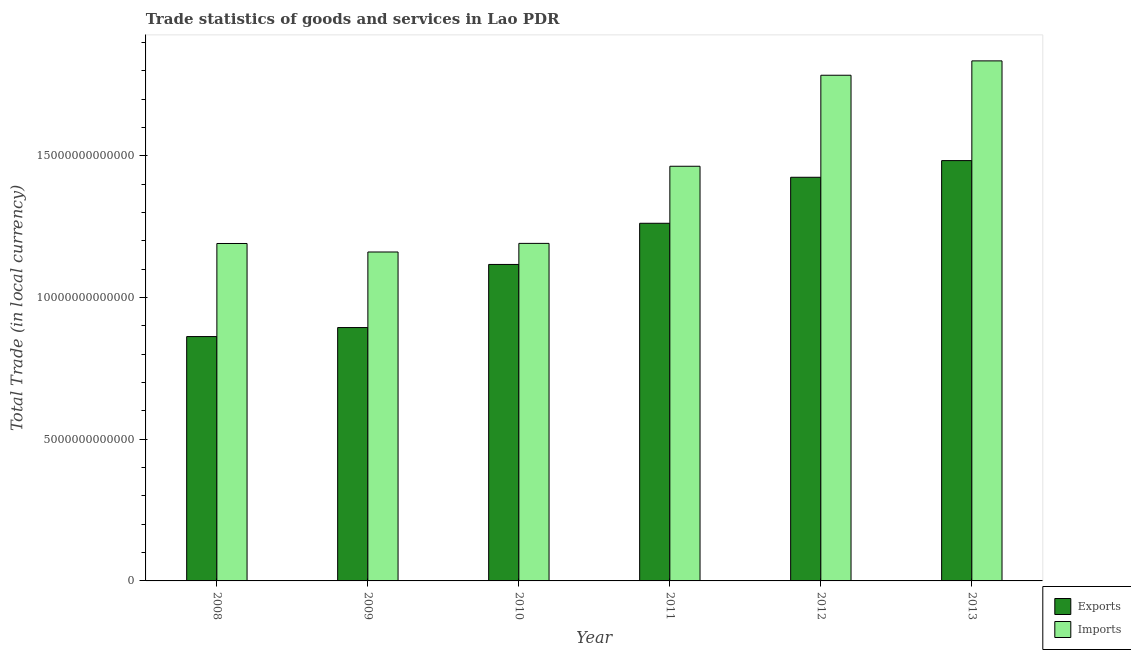How many different coloured bars are there?
Provide a succinct answer. 2. Are the number of bars per tick equal to the number of legend labels?
Provide a short and direct response. Yes. How many bars are there on the 5th tick from the left?
Give a very brief answer. 2. What is the export of goods and services in 2008?
Ensure brevity in your answer.  8.62e+12. Across all years, what is the maximum export of goods and services?
Keep it short and to the point. 1.48e+13. Across all years, what is the minimum export of goods and services?
Provide a succinct answer. 8.62e+12. What is the total export of goods and services in the graph?
Provide a succinct answer. 7.04e+13. What is the difference between the export of goods and services in 2009 and that in 2013?
Ensure brevity in your answer.  -5.89e+12. What is the difference between the imports of goods and services in 2009 and the export of goods and services in 2013?
Provide a short and direct response. -6.74e+12. What is the average export of goods and services per year?
Keep it short and to the point. 1.17e+13. What is the ratio of the imports of goods and services in 2009 to that in 2013?
Your response must be concise. 0.63. What is the difference between the highest and the second highest imports of goods and services?
Make the answer very short. 5.07e+11. What is the difference between the highest and the lowest imports of goods and services?
Your answer should be compact. 6.74e+12. In how many years, is the export of goods and services greater than the average export of goods and services taken over all years?
Your response must be concise. 3. What does the 1st bar from the left in 2008 represents?
Provide a succinct answer. Exports. What does the 2nd bar from the right in 2013 represents?
Make the answer very short. Exports. How many bars are there?
Your answer should be compact. 12. Are all the bars in the graph horizontal?
Your response must be concise. No. What is the difference between two consecutive major ticks on the Y-axis?
Offer a very short reply. 5.00e+12. Does the graph contain any zero values?
Make the answer very short. No. Does the graph contain grids?
Your answer should be compact. No. What is the title of the graph?
Your response must be concise. Trade statistics of goods and services in Lao PDR. What is the label or title of the Y-axis?
Provide a succinct answer. Total Trade (in local currency). What is the Total Trade (in local currency) of Exports in 2008?
Give a very brief answer. 8.62e+12. What is the Total Trade (in local currency) of Imports in 2008?
Offer a very short reply. 1.19e+13. What is the Total Trade (in local currency) of Exports in 2009?
Your answer should be compact. 8.94e+12. What is the Total Trade (in local currency) in Imports in 2009?
Keep it short and to the point. 1.16e+13. What is the Total Trade (in local currency) of Exports in 2010?
Provide a succinct answer. 1.12e+13. What is the Total Trade (in local currency) in Imports in 2010?
Make the answer very short. 1.19e+13. What is the Total Trade (in local currency) of Exports in 2011?
Offer a very short reply. 1.26e+13. What is the Total Trade (in local currency) of Imports in 2011?
Keep it short and to the point. 1.46e+13. What is the Total Trade (in local currency) in Exports in 2012?
Offer a very short reply. 1.42e+13. What is the Total Trade (in local currency) of Imports in 2012?
Keep it short and to the point. 1.78e+13. What is the Total Trade (in local currency) of Exports in 2013?
Make the answer very short. 1.48e+13. What is the Total Trade (in local currency) in Imports in 2013?
Offer a very short reply. 1.83e+13. Across all years, what is the maximum Total Trade (in local currency) in Exports?
Provide a short and direct response. 1.48e+13. Across all years, what is the maximum Total Trade (in local currency) of Imports?
Give a very brief answer. 1.83e+13. Across all years, what is the minimum Total Trade (in local currency) in Exports?
Offer a terse response. 8.62e+12. Across all years, what is the minimum Total Trade (in local currency) in Imports?
Give a very brief answer. 1.16e+13. What is the total Total Trade (in local currency) in Exports in the graph?
Provide a succinct answer. 7.04e+13. What is the total Total Trade (in local currency) of Imports in the graph?
Keep it short and to the point. 8.62e+13. What is the difference between the Total Trade (in local currency) in Exports in 2008 and that in 2009?
Make the answer very short. -3.18e+11. What is the difference between the Total Trade (in local currency) in Imports in 2008 and that in 2009?
Your response must be concise. 3.00e+11. What is the difference between the Total Trade (in local currency) in Exports in 2008 and that in 2010?
Make the answer very short. -2.54e+12. What is the difference between the Total Trade (in local currency) in Imports in 2008 and that in 2010?
Ensure brevity in your answer.  -4.09e+09. What is the difference between the Total Trade (in local currency) in Exports in 2008 and that in 2011?
Ensure brevity in your answer.  -4.00e+12. What is the difference between the Total Trade (in local currency) of Imports in 2008 and that in 2011?
Make the answer very short. -2.72e+12. What is the difference between the Total Trade (in local currency) of Exports in 2008 and that in 2012?
Your answer should be very brief. -5.62e+12. What is the difference between the Total Trade (in local currency) of Imports in 2008 and that in 2012?
Your answer should be compact. -5.94e+12. What is the difference between the Total Trade (in local currency) of Exports in 2008 and that in 2013?
Your response must be concise. -6.21e+12. What is the difference between the Total Trade (in local currency) of Imports in 2008 and that in 2013?
Keep it short and to the point. -6.44e+12. What is the difference between the Total Trade (in local currency) in Exports in 2009 and that in 2010?
Provide a succinct answer. -2.23e+12. What is the difference between the Total Trade (in local currency) of Imports in 2009 and that in 2010?
Make the answer very short. -3.04e+11. What is the difference between the Total Trade (in local currency) of Exports in 2009 and that in 2011?
Your answer should be very brief. -3.68e+12. What is the difference between the Total Trade (in local currency) of Imports in 2009 and that in 2011?
Offer a very short reply. -3.02e+12. What is the difference between the Total Trade (in local currency) in Exports in 2009 and that in 2012?
Your answer should be very brief. -5.30e+12. What is the difference between the Total Trade (in local currency) of Imports in 2009 and that in 2012?
Ensure brevity in your answer.  -6.24e+12. What is the difference between the Total Trade (in local currency) of Exports in 2009 and that in 2013?
Your answer should be compact. -5.89e+12. What is the difference between the Total Trade (in local currency) of Imports in 2009 and that in 2013?
Provide a succinct answer. -6.74e+12. What is the difference between the Total Trade (in local currency) of Exports in 2010 and that in 2011?
Your response must be concise. -1.45e+12. What is the difference between the Total Trade (in local currency) of Imports in 2010 and that in 2011?
Your answer should be very brief. -2.72e+12. What is the difference between the Total Trade (in local currency) of Exports in 2010 and that in 2012?
Provide a succinct answer. -3.08e+12. What is the difference between the Total Trade (in local currency) of Imports in 2010 and that in 2012?
Make the answer very short. -5.93e+12. What is the difference between the Total Trade (in local currency) in Exports in 2010 and that in 2013?
Make the answer very short. -3.66e+12. What is the difference between the Total Trade (in local currency) of Imports in 2010 and that in 2013?
Offer a terse response. -6.44e+12. What is the difference between the Total Trade (in local currency) in Exports in 2011 and that in 2012?
Make the answer very short. -1.62e+12. What is the difference between the Total Trade (in local currency) of Imports in 2011 and that in 2012?
Offer a very short reply. -3.21e+12. What is the difference between the Total Trade (in local currency) of Exports in 2011 and that in 2013?
Provide a succinct answer. -2.21e+12. What is the difference between the Total Trade (in local currency) of Imports in 2011 and that in 2013?
Provide a short and direct response. -3.72e+12. What is the difference between the Total Trade (in local currency) in Exports in 2012 and that in 2013?
Offer a very short reply. -5.88e+11. What is the difference between the Total Trade (in local currency) in Imports in 2012 and that in 2013?
Offer a terse response. -5.07e+11. What is the difference between the Total Trade (in local currency) in Exports in 2008 and the Total Trade (in local currency) in Imports in 2009?
Your response must be concise. -2.98e+12. What is the difference between the Total Trade (in local currency) in Exports in 2008 and the Total Trade (in local currency) in Imports in 2010?
Provide a short and direct response. -3.29e+12. What is the difference between the Total Trade (in local currency) in Exports in 2008 and the Total Trade (in local currency) in Imports in 2011?
Your answer should be compact. -6.01e+12. What is the difference between the Total Trade (in local currency) of Exports in 2008 and the Total Trade (in local currency) of Imports in 2012?
Give a very brief answer. -9.22e+12. What is the difference between the Total Trade (in local currency) of Exports in 2008 and the Total Trade (in local currency) of Imports in 2013?
Make the answer very short. -9.73e+12. What is the difference between the Total Trade (in local currency) of Exports in 2009 and the Total Trade (in local currency) of Imports in 2010?
Your answer should be very brief. -2.97e+12. What is the difference between the Total Trade (in local currency) in Exports in 2009 and the Total Trade (in local currency) in Imports in 2011?
Offer a terse response. -5.69e+12. What is the difference between the Total Trade (in local currency) of Exports in 2009 and the Total Trade (in local currency) of Imports in 2012?
Your answer should be very brief. -8.90e+12. What is the difference between the Total Trade (in local currency) of Exports in 2009 and the Total Trade (in local currency) of Imports in 2013?
Your answer should be compact. -9.41e+12. What is the difference between the Total Trade (in local currency) in Exports in 2010 and the Total Trade (in local currency) in Imports in 2011?
Provide a short and direct response. -3.46e+12. What is the difference between the Total Trade (in local currency) in Exports in 2010 and the Total Trade (in local currency) in Imports in 2012?
Offer a terse response. -6.67e+12. What is the difference between the Total Trade (in local currency) of Exports in 2010 and the Total Trade (in local currency) of Imports in 2013?
Provide a succinct answer. -7.18e+12. What is the difference between the Total Trade (in local currency) in Exports in 2011 and the Total Trade (in local currency) in Imports in 2012?
Keep it short and to the point. -5.22e+12. What is the difference between the Total Trade (in local currency) of Exports in 2011 and the Total Trade (in local currency) of Imports in 2013?
Ensure brevity in your answer.  -5.73e+12. What is the difference between the Total Trade (in local currency) of Exports in 2012 and the Total Trade (in local currency) of Imports in 2013?
Provide a succinct answer. -4.11e+12. What is the average Total Trade (in local currency) of Exports per year?
Your answer should be very brief. 1.17e+13. What is the average Total Trade (in local currency) in Imports per year?
Make the answer very short. 1.44e+13. In the year 2008, what is the difference between the Total Trade (in local currency) in Exports and Total Trade (in local currency) in Imports?
Offer a terse response. -3.28e+12. In the year 2009, what is the difference between the Total Trade (in local currency) in Exports and Total Trade (in local currency) in Imports?
Ensure brevity in your answer.  -2.67e+12. In the year 2010, what is the difference between the Total Trade (in local currency) in Exports and Total Trade (in local currency) in Imports?
Keep it short and to the point. -7.43e+11. In the year 2011, what is the difference between the Total Trade (in local currency) of Exports and Total Trade (in local currency) of Imports?
Offer a terse response. -2.01e+12. In the year 2012, what is the difference between the Total Trade (in local currency) in Exports and Total Trade (in local currency) in Imports?
Provide a short and direct response. -3.60e+12. In the year 2013, what is the difference between the Total Trade (in local currency) of Exports and Total Trade (in local currency) of Imports?
Give a very brief answer. -3.52e+12. What is the ratio of the Total Trade (in local currency) of Exports in 2008 to that in 2009?
Keep it short and to the point. 0.96. What is the ratio of the Total Trade (in local currency) of Imports in 2008 to that in 2009?
Offer a terse response. 1.03. What is the ratio of the Total Trade (in local currency) in Exports in 2008 to that in 2010?
Your answer should be compact. 0.77. What is the ratio of the Total Trade (in local currency) of Imports in 2008 to that in 2010?
Make the answer very short. 1. What is the ratio of the Total Trade (in local currency) of Exports in 2008 to that in 2011?
Make the answer very short. 0.68. What is the ratio of the Total Trade (in local currency) of Imports in 2008 to that in 2011?
Offer a very short reply. 0.81. What is the ratio of the Total Trade (in local currency) in Exports in 2008 to that in 2012?
Your answer should be very brief. 0.61. What is the ratio of the Total Trade (in local currency) in Imports in 2008 to that in 2012?
Provide a short and direct response. 0.67. What is the ratio of the Total Trade (in local currency) in Exports in 2008 to that in 2013?
Your answer should be very brief. 0.58. What is the ratio of the Total Trade (in local currency) of Imports in 2008 to that in 2013?
Provide a short and direct response. 0.65. What is the ratio of the Total Trade (in local currency) in Exports in 2009 to that in 2010?
Offer a terse response. 0.8. What is the ratio of the Total Trade (in local currency) in Imports in 2009 to that in 2010?
Your answer should be compact. 0.97. What is the ratio of the Total Trade (in local currency) in Exports in 2009 to that in 2011?
Keep it short and to the point. 0.71. What is the ratio of the Total Trade (in local currency) in Imports in 2009 to that in 2011?
Make the answer very short. 0.79. What is the ratio of the Total Trade (in local currency) of Exports in 2009 to that in 2012?
Ensure brevity in your answer.  0.63. What is the ratio of the Total Trade (in local currency) in Imports in 2009 to that in 2012?
Offer a very short reply. 0.65. What is the ratio of the Total Trade (in local currency) in Exports in 2009 to that in 2013?
Ensure brevity in your answer.  0.6. What is the ratio of the Total Trade (in local currency) in Imports in 2009 to that in 2013?
Offer a very short reply. 0.63. What is the ratio of the Total Trade (in local currency) in Exports in 2010 to that in 2011?
Keep it short and to the point. 0.88. What is the ratio of the Total Trade (in local currency) of Imports in 2010 to that in 2011?
Your answer should be very brief. 0.81. What is the ratio of the Total Trade (in local currency) in Exports in 2010 to that in 2012?
Offer a very short reply. 0.78. What is the ratio of the Total Trade (in local currency) in Imports in 2010 to that in 2012?
Offer a terse response. 0.67. What is the ratio of the Total Trade (in local currency) of Exports in 2010 to that in 2013?
Make the answer very short. 0.75. What is the ratio of the Total Trade (in local currency) of Imports in 2010 to that in 2013?
Keep it short and to the point. 0.65. What is the ratio of the Total Trade (in local currency) of Exports in 2011 to that in 2012?
Provide a short and direct response. 0.89. What is the ratio of the Total Trade (in local currency) in Imports in 2011 to that in 2012?
Offer a very short reply. 0.82. What is the ratio of the Total Trade (in local currency) in Exports in 2011 to that in 2013?
Provide a succinct answer. 0.85. What is the ratio of the Total Trade (in local currency) of Imports in 2011 to that in 2013?
Give a very brief answer. 0.8. What is the ratio of the Total Trade (in local currency) of Exports in 2012 to that in 2013?
Provide a succinct answer. 0.96. What is the ratio of the Total Trade (in local currency) in Imports in 2012 to that in 2013?
Keep it short and to the point. 0.97. What is the difference between the highest and the second highest Total Trade (in local currency) in Exports?
Offer a very short reply. 5.88e+11. What is the difference between the highest and the second highest Total Trade (in local currency) of Imports?
Your response must be concise. 5.07e+11. What is the difference between the highest and the lowest Total Trade (in local currency) of Exports?
Your answer should be very brief. 6.21e+12. What is the difference between the highest and the lowest Total Trade (in local currency) in Imports?
Provide a succinct answer. 6.74e+12. 